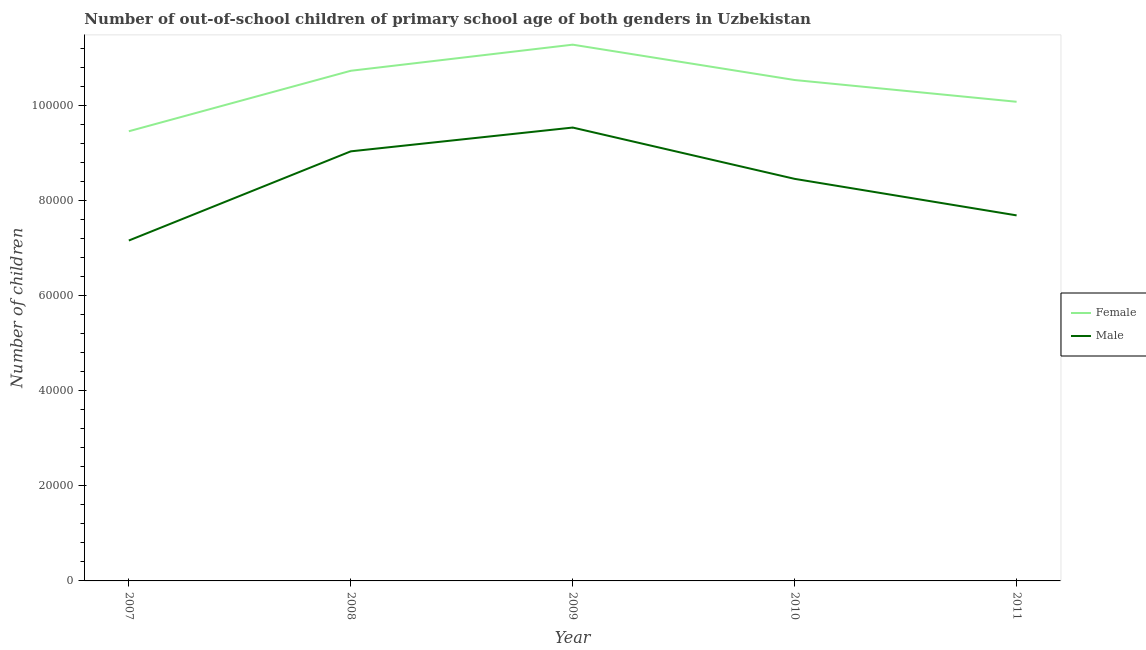How many different coloured lines are there?
Your answer should be compact. 2. Does the line corresponding to number of female out-of-school students intersect with the line corresponding to number of male out-of-school students?
Offer a very short reply. No. What is the number of female out-of-school students in 2008?
Your response must be concise. 1.07e+05. Across all years, what is the maximum number of male out-of-school students?
Offer a very short reply. 9.54e+04. Across all years, what is the minimum number of female out-of-school students?
Your answer should be compact. 9.46e+04. In which year was the number of male out-of-school students minimum?
Make the answer very short. 2007. What is the total number of male out-of-school students in the graph?
Offer a terse response. 4.19e+05. What is the difference between the number of male out-of-school students in 2008 and that in 2010?
Your answer should be compact. 5788. What is the difference between the number of female out-of-school students in 2009 and the number of male out-of-school students in 2008?
Offer a terse response. 2.24e+04. What is the average number of female out-of-school students per year?
Offer a very short reply. 1.04e+05. In the year 2008, what is the difference between the number of male out-of-school students and number of female out-of-school students?
Your answer should be compact. -1.69e+04. In how many years, is the number of female out-of-school students greater than 92000?
Your response must be concise. 5. What is the ratio of the number of male out-of-school students in 2007 to that in 2009?
Your answer should be compact. 0.75. What is the difference between the highest and the second highest number of female out-of-school students?
Provide a short and direct response. 5492. What is the difference between the highest and the lowest number of female out-of-school students?
Your response must be concise. 1.82e+04. In how many years, is the number of female out-of-school students greater than the average number of female out-of-school students taken over all years?
Your answer should be very brief. 3. Is the number of male out-of-school students strictly less than the number of female out-of-school students over the years?
Provide a short and direct response. Yes. What is the difference between two consecutive major ticks on the Y-axis?
Provide a succinct answer. 2.00e+04. Does the graph contain any zero values?
Keep it short and to the point. No. Where does the legend appear in the graph?
Offer a very short reply. Center right. How many legend labels are there?
Make the answer very short. 2. What is the title of the graph?
Give a very brief answer. Number of out-of-school children of primary school age of both genders in Uzbekistan. Does "Number of arrivals" appear as one of the legend labels in the graph?
Provide a succinct answer. No. What is the label or title of the Y-axis?
Make the answer very short. Number of children. What is the Number of children in Female in 2007?
Ensure brevity in your answer.  9.46e+04. What is the Number of children of Male in 2007?
Your answer should be compact. 7.16e+04. What is the Number of children in Female in 2008?
Offer a terse response. 1.07e+05. What is the Number of children of Male in 2008?
Provide a short and direct response. 9.04e+04. What is the Number of children in Female in 2009?
Provide a succinct answer. 1.13e+05. What is the Number of children in Male in 2009?
Offer a very short reply. 9.54e+04. What is the Number of children in Female in 2010?
Your response must be concise. 1.05e+05. What is the Number of children of Male in 2010?
Ensure brevity in your answer.  8.46e+04. What is the Number of children of Female in 2011?
Offer a terse response. 1.01e+05. What is the Number of children in Male in 2011?
Make the answer very short. 7.69e+04. Across all years, what is the maximum Number of children of Female?
Ensure brevity in your answer.  1.13e+05. Across all years, what is the maximum Number of children of Male?
Make the answer very short. 9.54e+04. Across all years, what is the minimum Number of children of Female?
Your answer should be very brief. 9.46e+04. Across all years, what is the minimum Number of children of Male?
Your answer should be compact. 7.16e+04. What is the total Number of children in Female in the graph?
Provide a succinct answer. 5.21e+05. What is the total Number of children in Male in the graph?
Offer a very short reply. 4.19e+05. What is the difference between the Number of children of Female in 2007 and that in 2008?
Your answer should be very brief. -1.27e+04. What is the difference between the Number of children in Male in 2007 and that in 2008?
Offer a terse response. -1.88e+04. What is the difference between the Number of children in Female in 2007 and that in 2009?
Offer a terse response. -1.82e+04. What is the difference between the Number of children of Male in 2007 and that in 2009?
Provide a short and direct response. -2.38e+04. What is the difference between the Number of children in Female in 2007 and that in 2010?
Your response must be concise. -1.08e+04. What is the difference between the Number of children in Male in 2007 and that in 2010?
Your answer should be compact. -1.30e+04. What is the difference between the Number of children in Female in 2007 and that in 2011?
Provide a short and direct response. -6203. What is the difference between the Number of children in Male in 2007 and that in 2011?
Give a very brief answer. -5290. What is the difference between the Number of children in Female in 2008 and that in 2009?
Ensure brevity in your answer.  -5492. What is the difference between the Number of children in Male in 2008 and that in 2009?
Offer a terse response. -5005. What is the difference between the Number of children in Female in 2008 and that in 2010?
Provide a succinct answer. 1946. What is the difference between the Number of children of Male in 2008 and that in 2010?
Offer a terse response. 5788. What is the difference between the Number of children of Female in 2008 and that in 2011?
Your response must be concise. 6521. What is the difference between the Number of children in Male in 2008 and that in 2011?
Keep it short and to the point. 1.35e+04. What is the difference between the Number of children of Female in 2009 and that in 2010?
Your answer should be compact. 7438. What is the difference between the Number of children of Male in 2009 and that in 2010?
Give a very brief answer. 1.08e+04. What is the difference between the Number of children in Female in 2009 and that in 2011?
Offer a very short reply. 1.20e+04. What is the difference between the Number of children of Male in 2009 and that in 2011?
Give a very brief answer. 1.85e+04. What is the difference between the Number of children in Female in 2010 and that in 2011?
Your response must be concise. 4575. What is the difference between the Number of children in Male in 2010 and that in 2011?
Offer a very short reply. 7683. What is the difference between the Number of children in Female in 2007 and the Number of children in Male in 2008?
Your answer should be compact. 4225. What is the difference between the Number of children of Female in 2007 and the Number of children of Male in 2009?
Your answer should be compact. -780. What is the difference between the Number of children in Female in 2007 and the Number of children in Male in 2010?
Make the answer very short. 1.00e+04. What is the difference between the Number of children in Female in 2007 and the Number of children in Male in 2011?
Keep it short and to the point. 1.77e+04. What is the difference between the Number of children of Female in 2008 and the Number of children of Male in 2009?
Your answer should be compact. 1.19e+04. What is the difference between the Number of children of Female in 2008 and the Number of children of Male in 2010?
Provide a short and direct response. 2.27e+04. What is the difference between the Number of children of Female in 2008 and the Number of children of Male in 2011?
Offer a terse response. 3.04e+04. What is the difference between the Number of children in Female in 2009 and the Number of children in Male in 2010?
Your response must be concise. 2.82e+04. What is the difference between the Number of children in Female in 2009 and the Number of children in Male in 2011?
Make the answer very short. 3.59e+04. What is the difference between the Number of children in Female in 2010 and the Number of children in Male in 2011?
Your answer should be compact. 2.85e+04. What is the average Number of children of Female per year?
Offer a terse response. 1.04e+05. What is the average Number of children of Male per year?
Keep it short and to the point. 8.38e+04. In the year 2007, what is the difference between the Number of children in Female and Number of children in Male?
Your answer should be compact. 2.30e+04. In the year 2008, what is the difference between the Number of children of Female and Number of children of Male?
Provide a short and direct response. 1.69e+04. In the year 2009, what is the difference between the Number of children in Female and Number of children in Male?
Give a very brief answer. 1.74e+04. In the year 2010, what is the difference between the Number of children of Female and Number of children of Male?
Provide a succinct answer. 2.08e+04. In the year 2011, what is the difference between the Number of children of Female and Number of children of Male?
Your response must be concise. 2.39e+04. What is the ratio of the Number of children of Female in 2007 to that in 2008?
Ensure brevity in your answer.  0.88. What is the ratio of the Number of children of Male in 2007 to that in 2008?
Offer a very short reply. 0.79. What is the ratio of the Number of children in Female in 2007 to that in 2009?
Your answer should be very brief. 0.84. What is the ratio of the Number of children of Male in 2007 to that in 2009?
Ensure brevity in your answer.  0.75. What is the ratio of the Number of children in Female in 2007 to that in 2010?
Give a very brief answer. 0.9. What is the ratio of the Number of children of Male in 2007 to that in 2010?
Your answer should be compact. 0.85. What is the ratio of the Number of children in Female in 2007 to that in 2011?
Make the answer very short. 0.94. What is the ratio of the Number of children of Male in 2007 to that in 2011?
Offer a very short reply. 0.93. What is the ratio of the Number of children in Female in 2008 to that in 2009?
Your answer should be very brief. 0.95. What is the ratio of the Number of children of Male in 2008 to that in 2009?
Your answer should be compact. 0.95. What is the ratio of the Number of children in Female in 2008 to that in 2010?
Ensure brevity in your answer.  1.02. What is the ratio of the Number of children of Male in 2008 to that in 2010?
Provide a short and direct response. 1.07. What is the ratio of the Number of children of Female in 2008 to that in 2011?
Your answer should be compact. 1.06. What is the ratio of the Number of children in Male in 2008 to that in 2011?
Your response must be concise. 1.18. What is the ratio of the Number of children of Female in 2009 to that in 2010?
Offer a very short reply. 1.07. What is the ratio of the Number of children in Male in 2009 to that in 2010?
Make the answer very short. 1.13. What is the ratio of the Number of children of Female in 2009 to that in 2011?
Your answer should be compact. 1.12. What is the ratio of the Number of children in Male in 2009 to that in 2011?
Provide a succinct answer. 1.24. What is the ratio of the Number of children in Female in 2010 to that in 2011?
Your answer should be very brief. 1.05. What is the ratio of the Number of children of Male in 2010 to that in 2011?
Ensure brevity in your answer.  1.1. What is the difference between the highest and the second highest Number of children of Female?
Offer a terse response. 5492. What is the difference between the highest and the second highest Number of children in Male?
Your answer should be very brief. 5005. What is the difference between the highest and the lowest Number of children in Female?
Your answer should be compact. 1.82e+04. What is the difference between the highest and the lowest Number of children in Male?
Provide a short and direct response. 2.38e+04. 